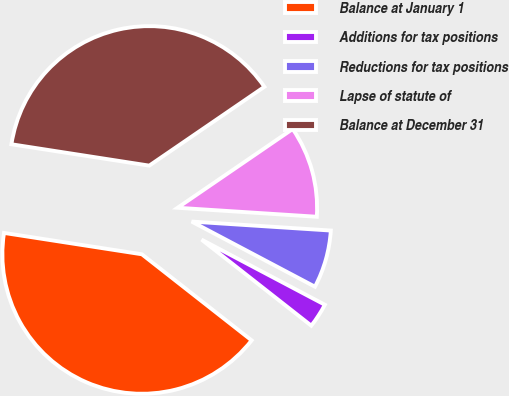<chart> <loc_0><loc_0><loc_500><loc_500><pie_chart><fcel>Balance at January 1<fcel>Additions for tax positions<fcel>Reductions for tax positions<fcel>Lapse of statute of<fcel>Balance at December 31<nl><fcel>41.86%<fcel>2.85%<fcel>6.71%<fcel>10.58%<fcel>38.0%<nl></chart> 